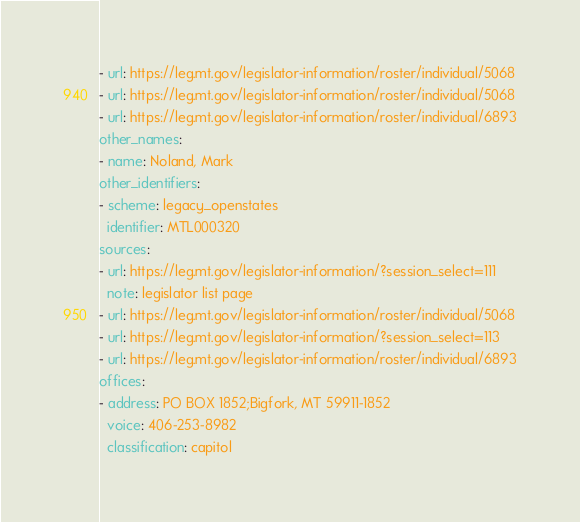<code> <loc_0><loc_0><loc_500><loc_500><_YAML_>- url: https://leg.mt.gov/legislator-information/roster/individual/5068
- url: https://leg.mt.gov/legislator-information/roster/individual/5068
- url: https://leg.mt.gov/legislator-information/roster/individual/6893
other_names:
- name: Noland, Mark
other_identifiers:
- scheme: legacy_openstates
  identifier: MTL000320
sources:
- url: https://leg.mt.gov/legislator-information/?session_select=111
  note: legislator list page
- url: https://leg.mt.gov/legislator-information/roster/individual/5068
- url: https://leg.mt.gov/legislator-information/?session_select=113
- url: https://leg.mt.gov/legislator-information/roster/individual/6893
offices:
- address: PO BOX 1852;Bigfork, MT 59911-1852
  voice: 406-253-8982
  classification: capitol
</code> 